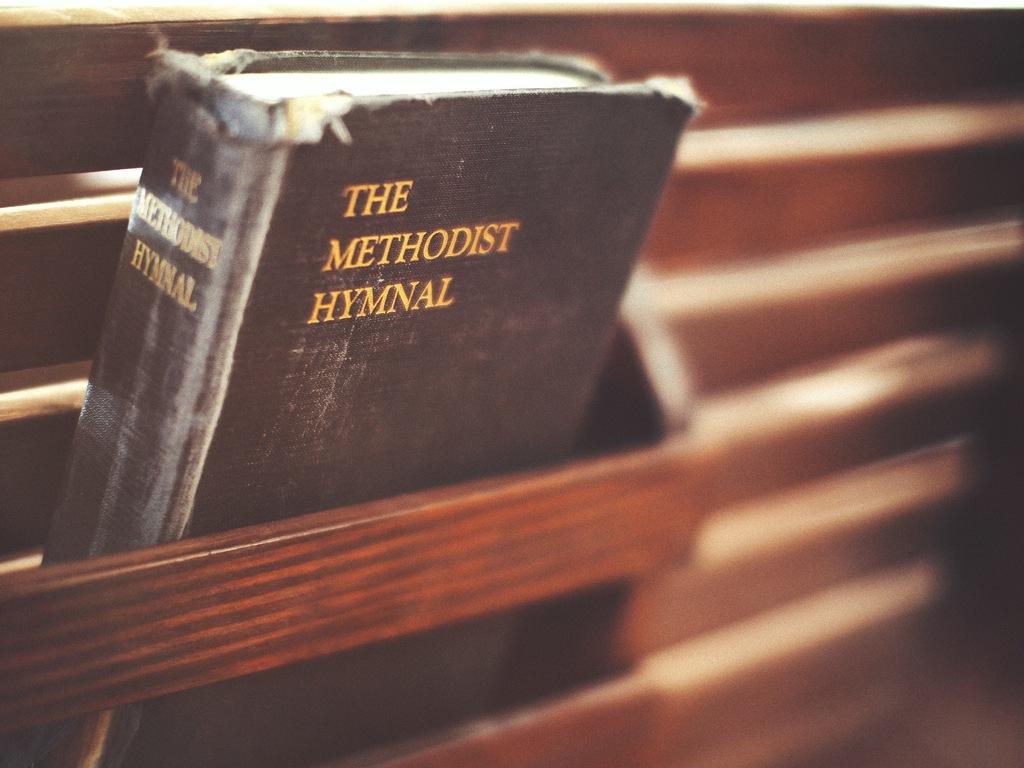What type of book is in the picture?
Give a very brief answer. The methodist hymnal. What color is the word "methodist" on the book cover?
Ensure brevity in your answer.  Gold. 